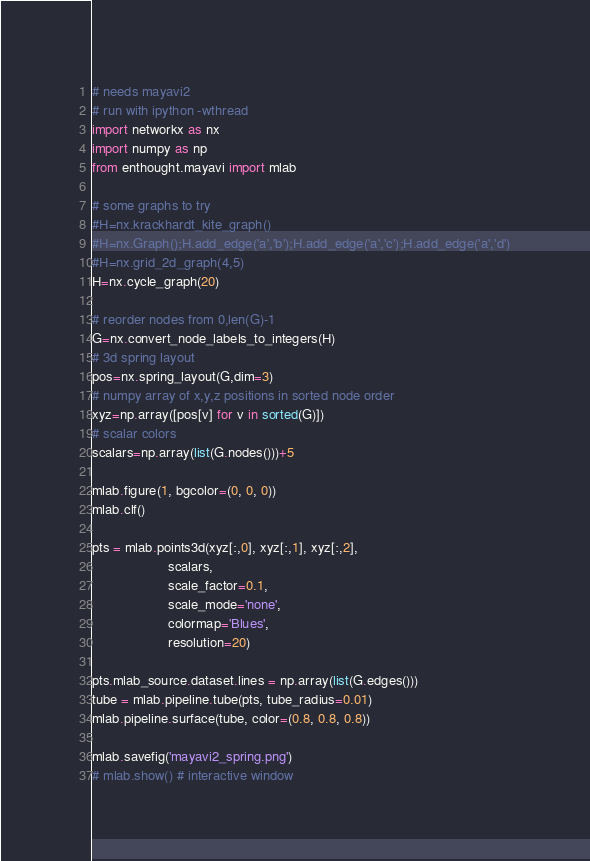Convert code to text. <code><loc_0><loc_0><loc_500><loc_500><_Python_># needs mayavi2 
# run with ipython -wthread
import networkx as nx
import numpy as np
from enthought.mayavi import mlab

# some graphs to try
#H=nx.krackhardt_kite_graph()
#H=nx.Graph();H.add_edge('a','b');H.add_edge('a','c');H.add_edge('a','d')
#H=nx.grid_2d_graph(4,5)
H=nx.cycle_graph(20)

# reorder nodes from 0,len(G)-1
G=nx.convert_node_labels_to_integers(H)
# 3d spring layout
pos=nx.spring_layout(G,dim=3)
# numpy array of x,y,z positions in sorted node order
xyz=np.array([pos[v] for v in sorted(G)])
# scalar colors
scalars=np.array(list(G.nodes()))+5

mlab.figure(1, bgcolor=(0, 0, 0))
mlab.clf()

pts = mlab.points3d(xyz[:,0], xyz[:,1], xyz[:,2],
                    scalars,
                    scale_factor=0.1,
                    scale_mode='none',
                    colormap='Blues',
                    resolution=20)
                                   
pts.mlab_source.dataset.lines = np.array(list(G.edges()))
tube = mlab.pipeline.tube(pts, tube_radius=0.01)
mlab.pipeline.surface(tube, color=(0.8, 0.8, 0.8))

mlab.savefig('mayavi2_spring.png')
# mlab.show() # interactive window
</code> 